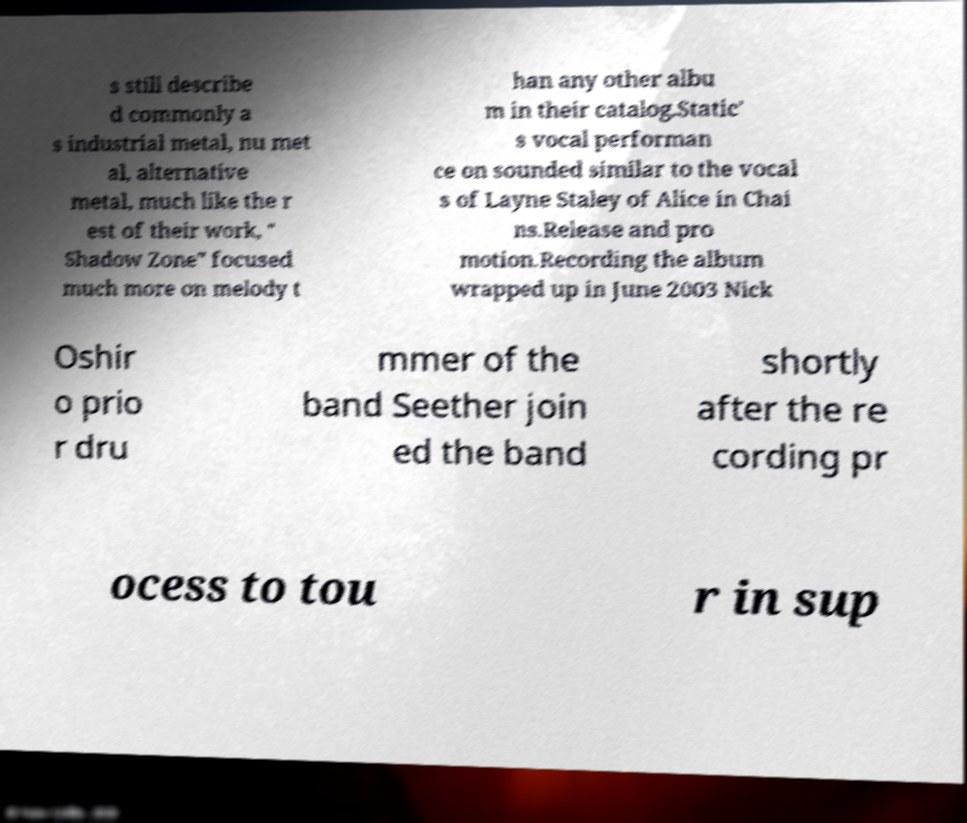Could you assist in decoding the text presented in this image and type it out clearly? s still describe d commonly a s industrial metal, nu met al, alternative metal, much like the r est of their work, " Shadow Zone" focused much more on melody t han any other albu m in their catalog.Static' s vocal performan ce on sounded similar to the vocal s of Layne Staley of Alice in Chai ns.Release and pro motion.Recording the album wrapped up in June 2003 Nick Oshir o prio r dru mmer of the band Seether join ed the band shortly after the re cording pr ocess to tou r in sup 